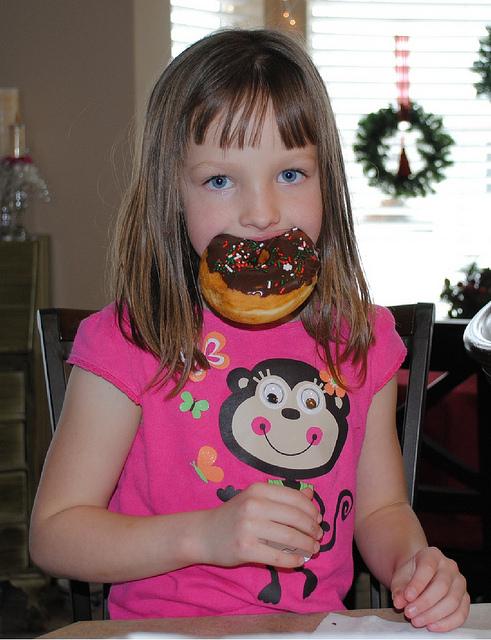Is the girl's hair curly or straight?
Write a very short answer. Straight. Is she eating pizza?
Keep it brief. No. Is there a blue ball in this picture?
Be succinct. No. Where is the child looking?
Short answer required. At camera. Was this picture taken in a restaurant?
Short answer required. No. Does this person respect authority?
Concise answer only. No. Is that healthy food?
Quick response, please. No. What does she have in her mouth?
Concise answer only. Donut. What is she eating?
Short answer required. Donut. What bird is featured on the woman's apron?
Short answer required. Monkey. What is the brand of sweatshirt the little girl is wearing?
Short answer required. Monkey. What food is the child eating?
Answer briefly. Donut. What does the little girl think is special about the day?
Write a very short answer. Donuts. What is this girl going to eat?
Quick response, please. Donut. Whose room are they in?
Short answer required. Kitchen. Is this donut unusually large?
Keep it brief. No. Is the girl wearing a dress?
Be succinct. No. Is the child elementary school age?
Keep it brief. Yes. Why is the baby eating with her hands?
Write a very short answer. Donut. What color is the girl's dress?
Keep it brief. Pink. What time of year is it?
Quick response, please. Christmas. What is this little girl celebrating?
Answer briefly. Christmas. What color is the girls hair?
Concise answer only. Brown. What is the girl eating?
Concise answer only. Donut. What is on the top of the donut?
Write a very short answer. Sprinkles. What animal is on the girl's shirt?
Be succinct. Monkey. Is this a boy or a girl?
Be succinct. Girl. 